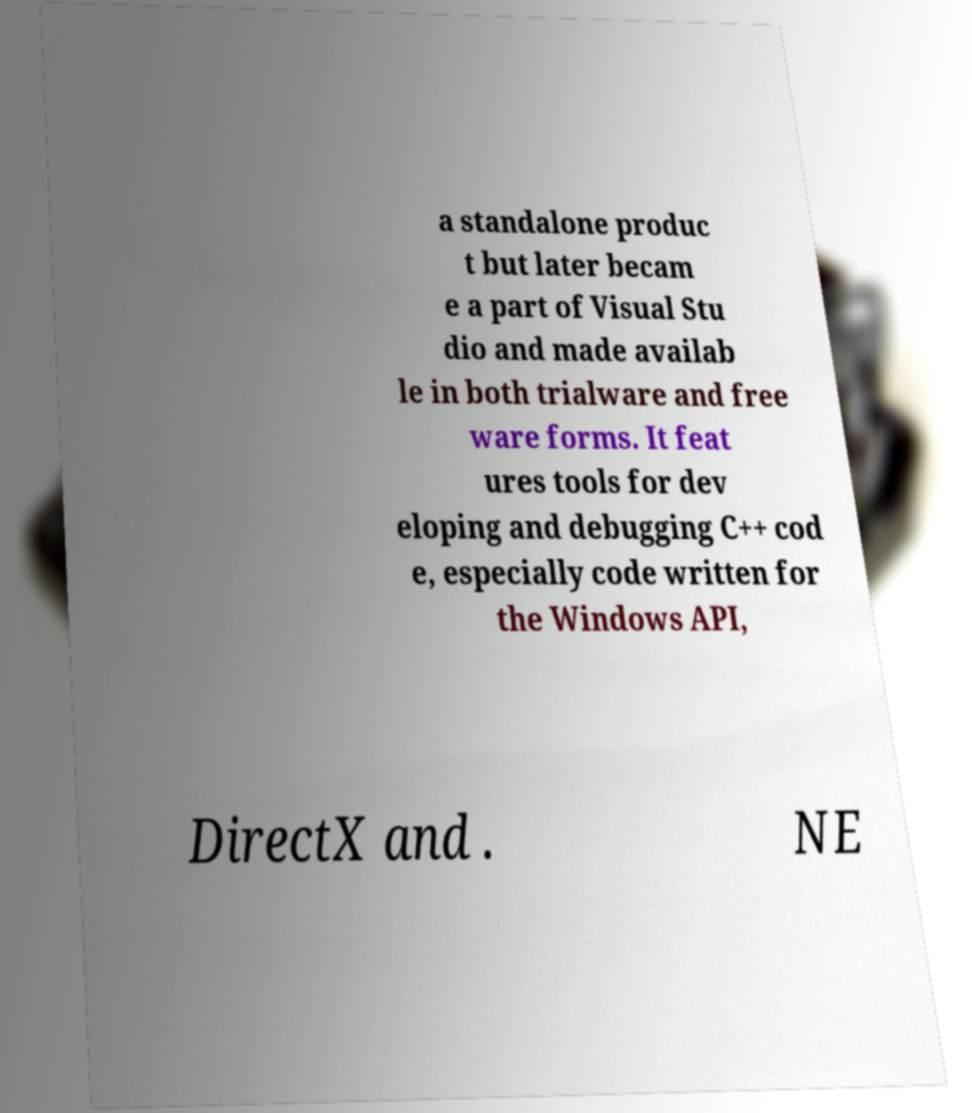Could you extract and type out the text from this image? a standalone produc t but later becam e a part of Visual Stu dio and made availab le in both trialware and free ware forms. It feat ures tools for dev eloping and debugging C++ cod e, especially code written for the Windows API, DirectX and . NE 